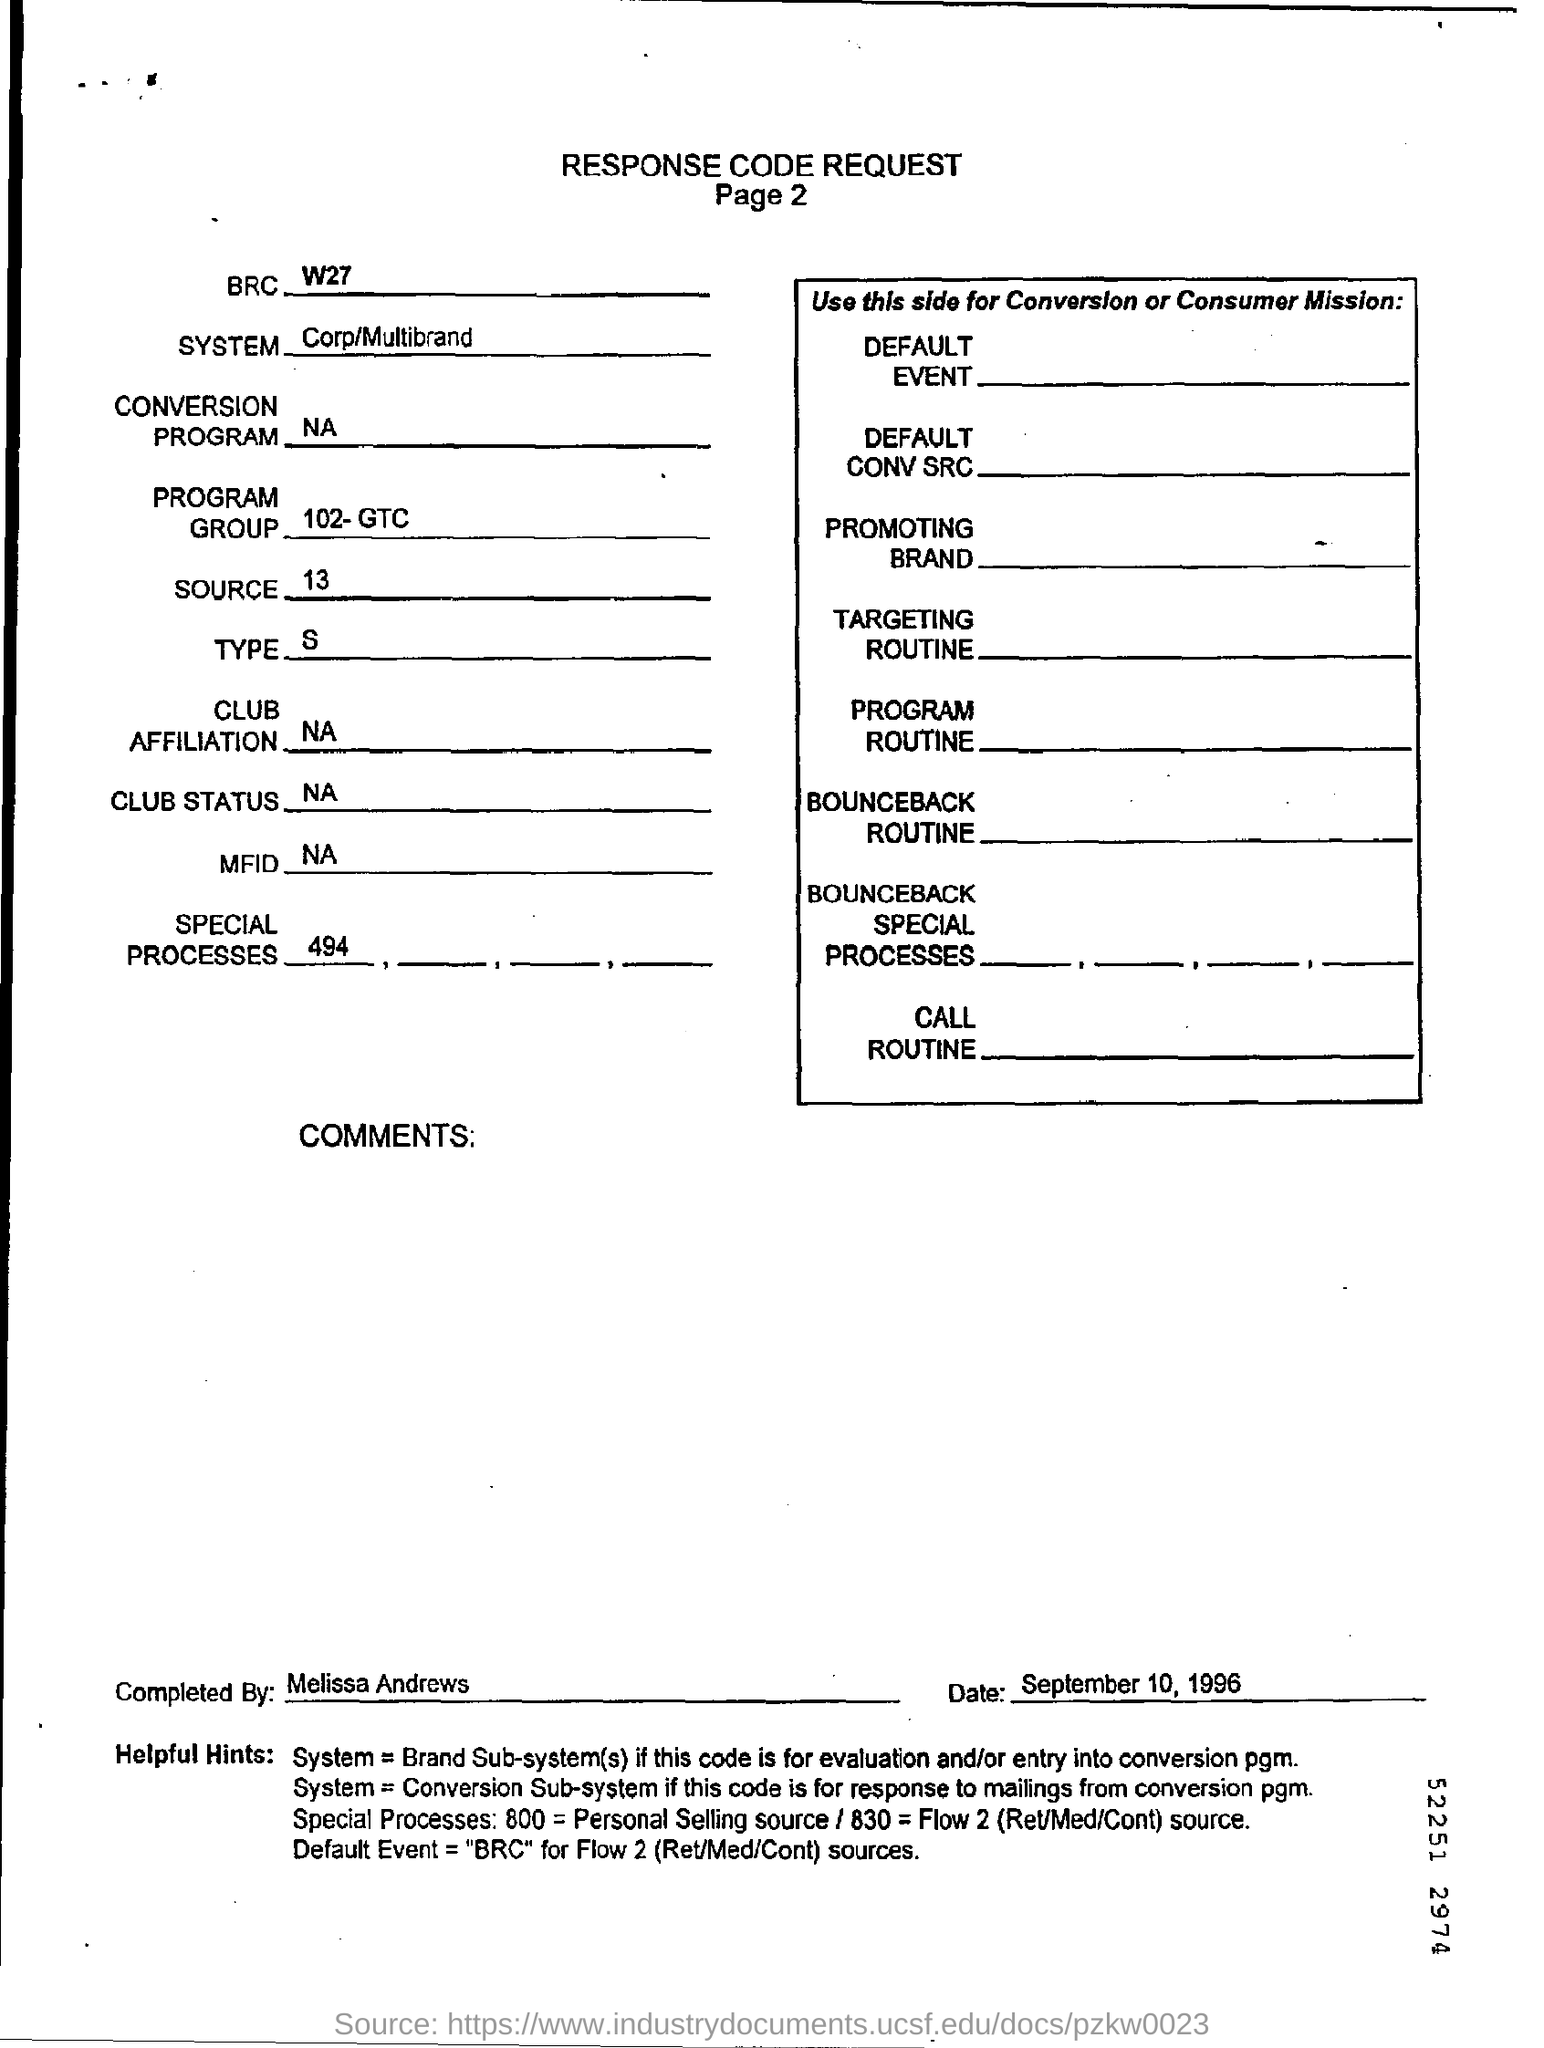Highlight a few significant elements in this photo. The system name is Corp/Multibrand. It is declared that the form was completed by Melissa Andrews. The date printed on the form is September 10, 1996. 